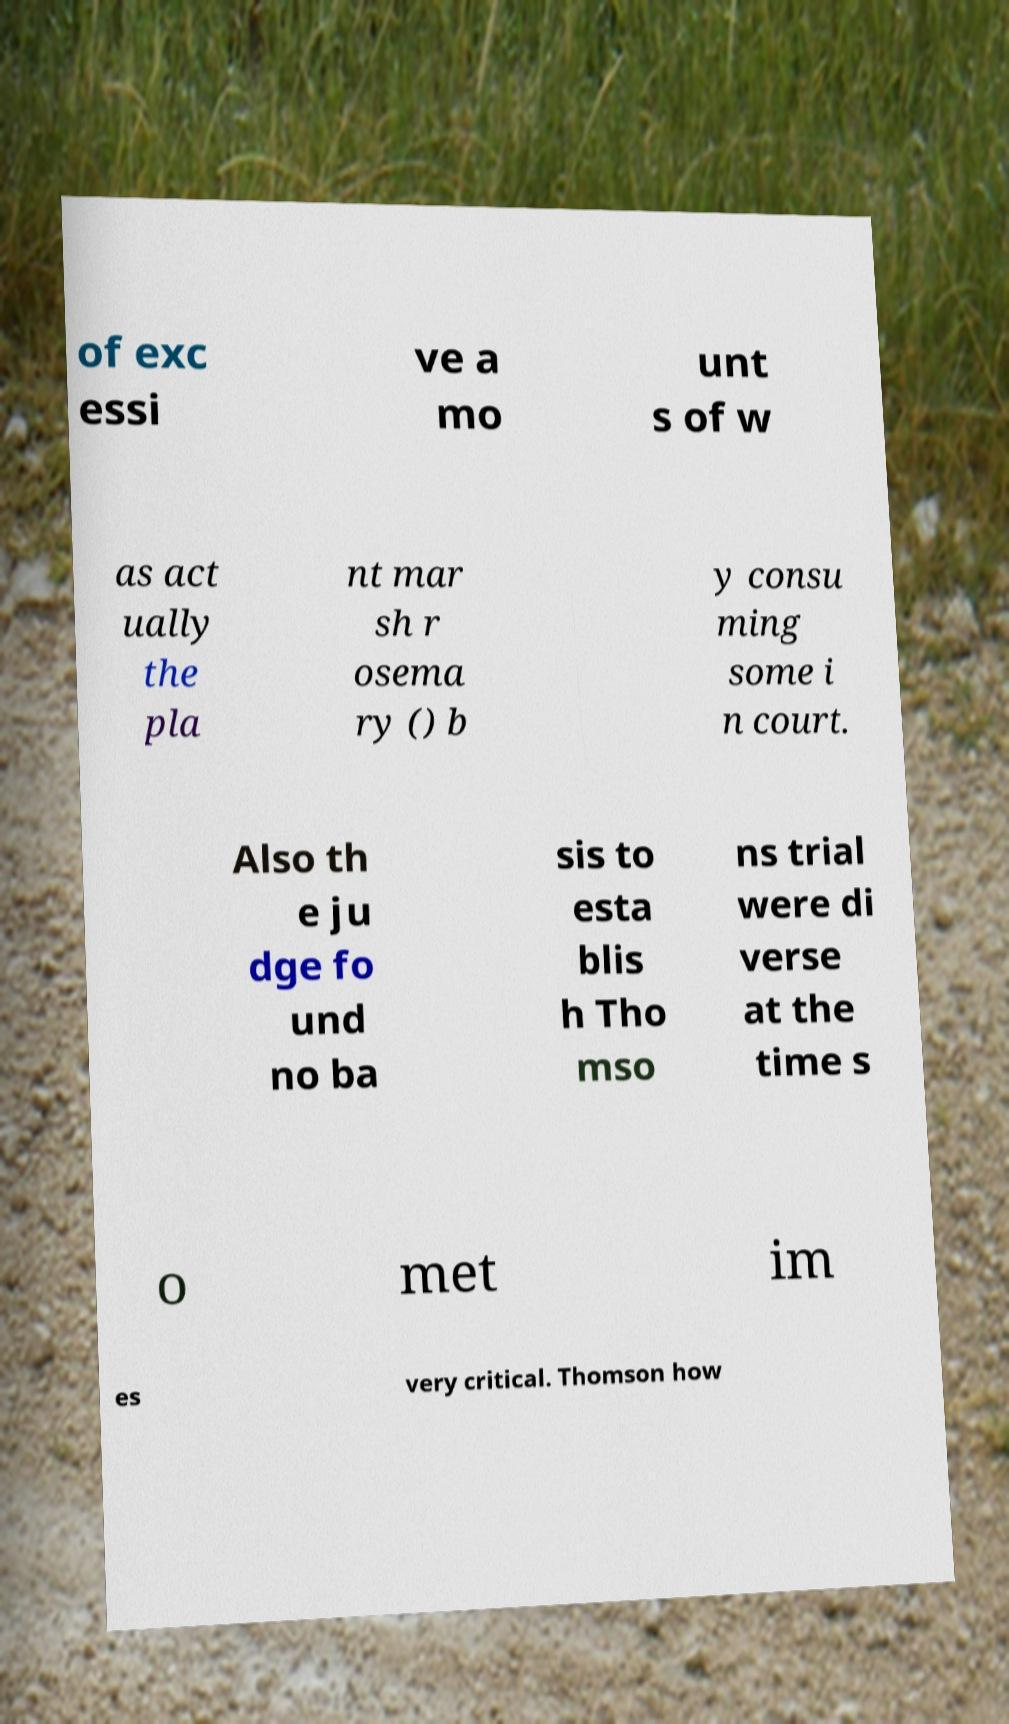Please identify and transcribe the text found in this image. of exc essi ve a mo unt s of w as act ually the pla nt mar sh r osema ry () b y consu ming some i n court. Also th e ju dge fo und no ba sis to esta blis h Tho mso ns trial were di verse at the time s o met im es very critical. Thomson how 